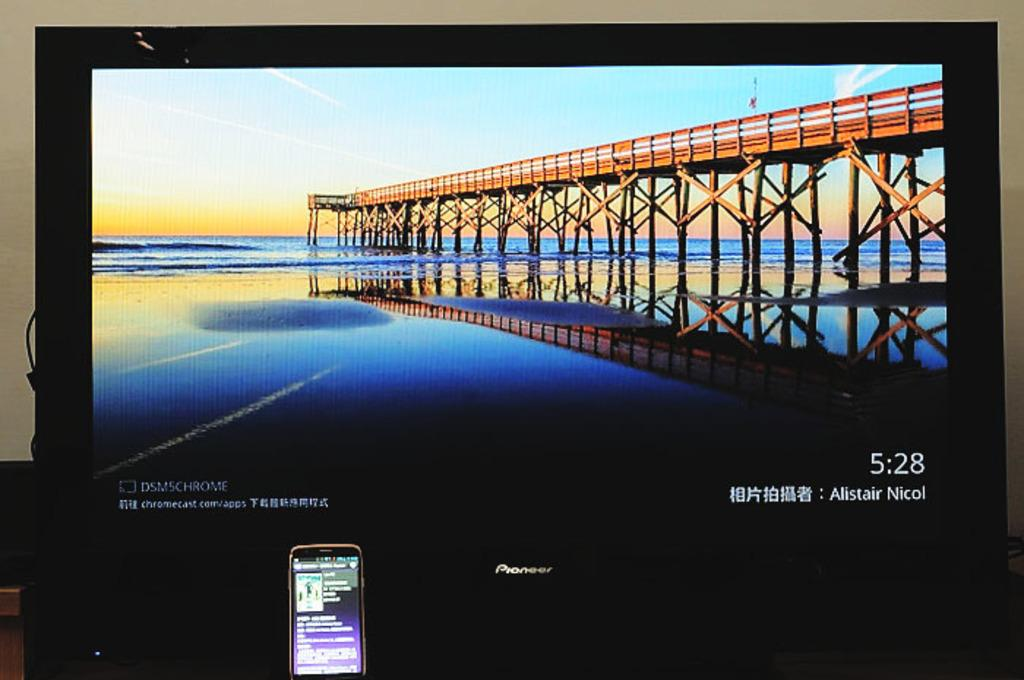Provide a one-sentence caption for the provided image. A computer monitor shows a picture of a pier and has the time listed as 5:28. 